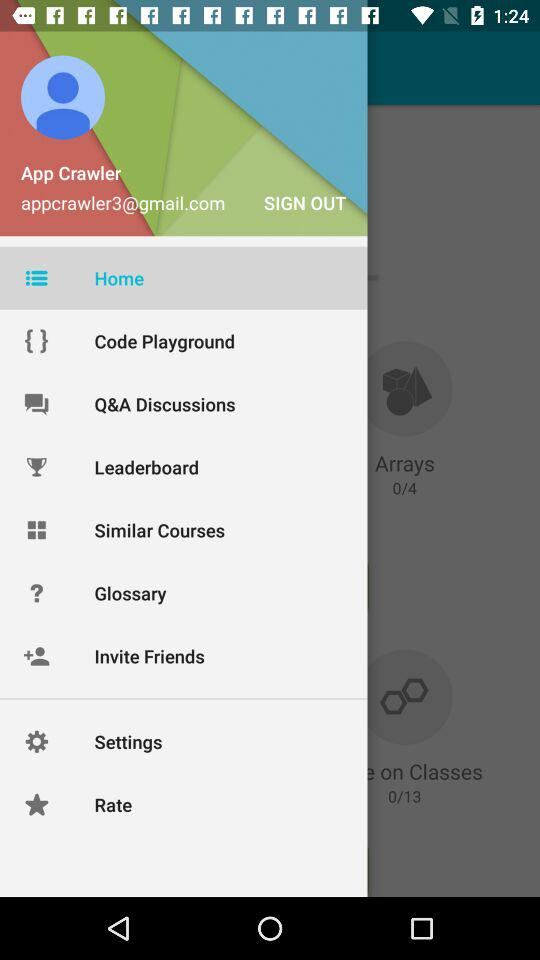What is the email address? The email address is appcrawler3@gmail.com. 